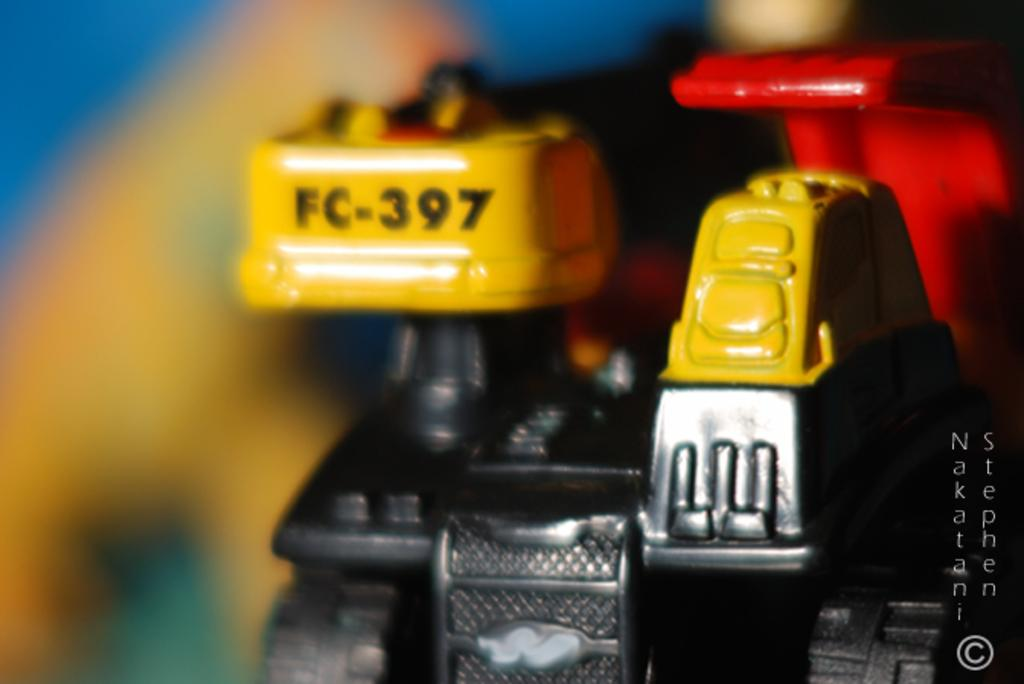<image>
Write a terse but informative summary of the picture. A black and yellow piece of equipment with the labeling FC-397 on it. 